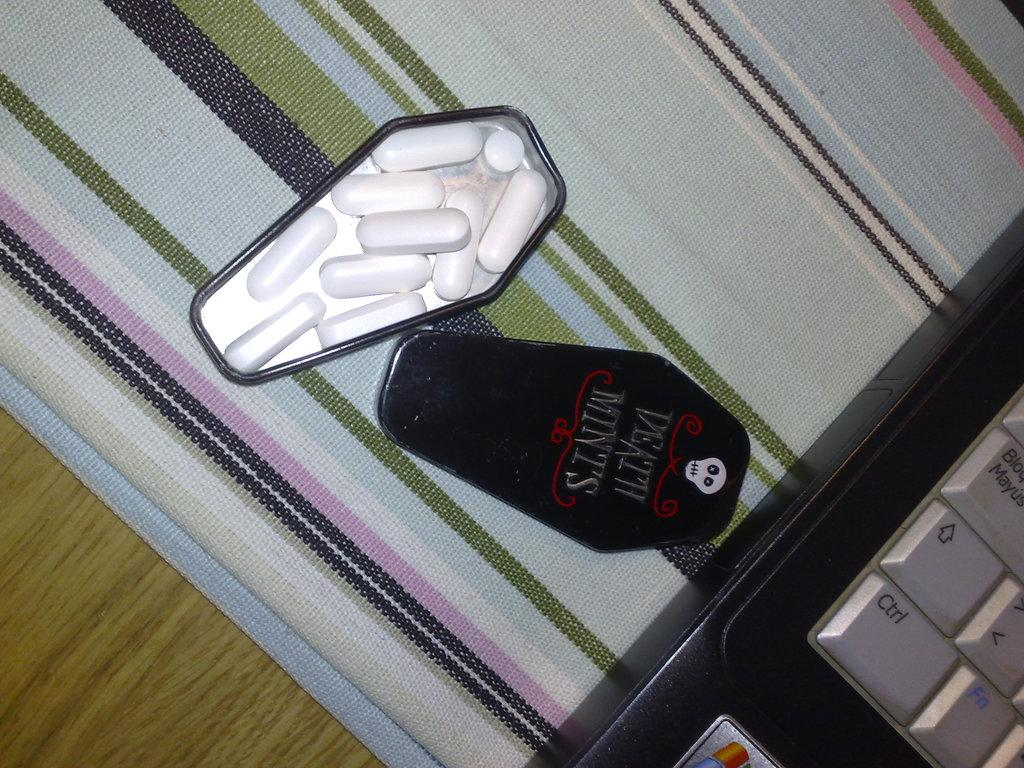<image>
Render a clear and concise summary of the photo. Box of mints called Death Mints next to a laptop. 